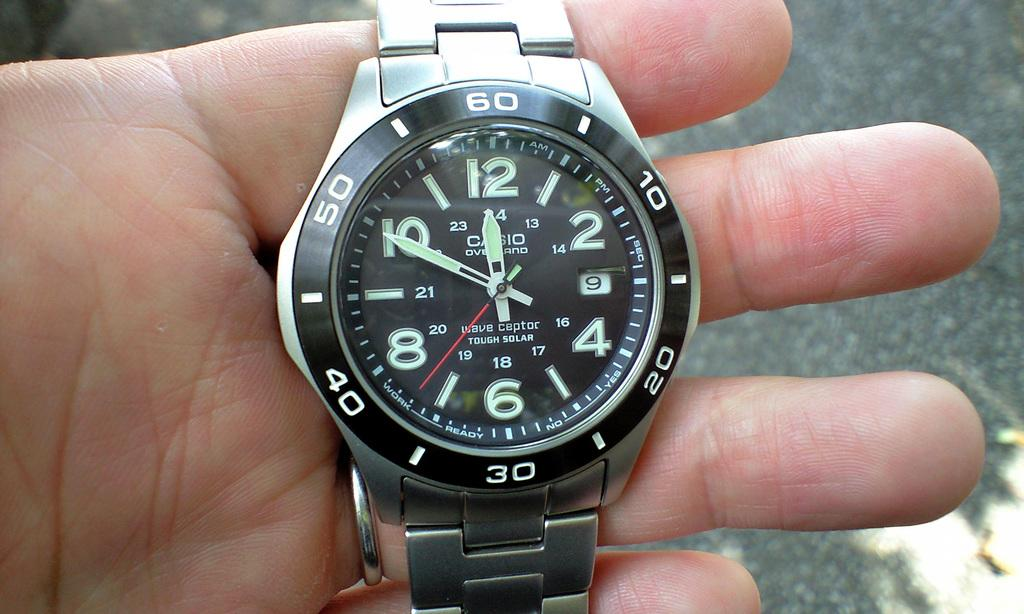<image>
Offer a succinct explanation of the picture presented. The wave ceptor watch has a solar feature and glows in the dark. 